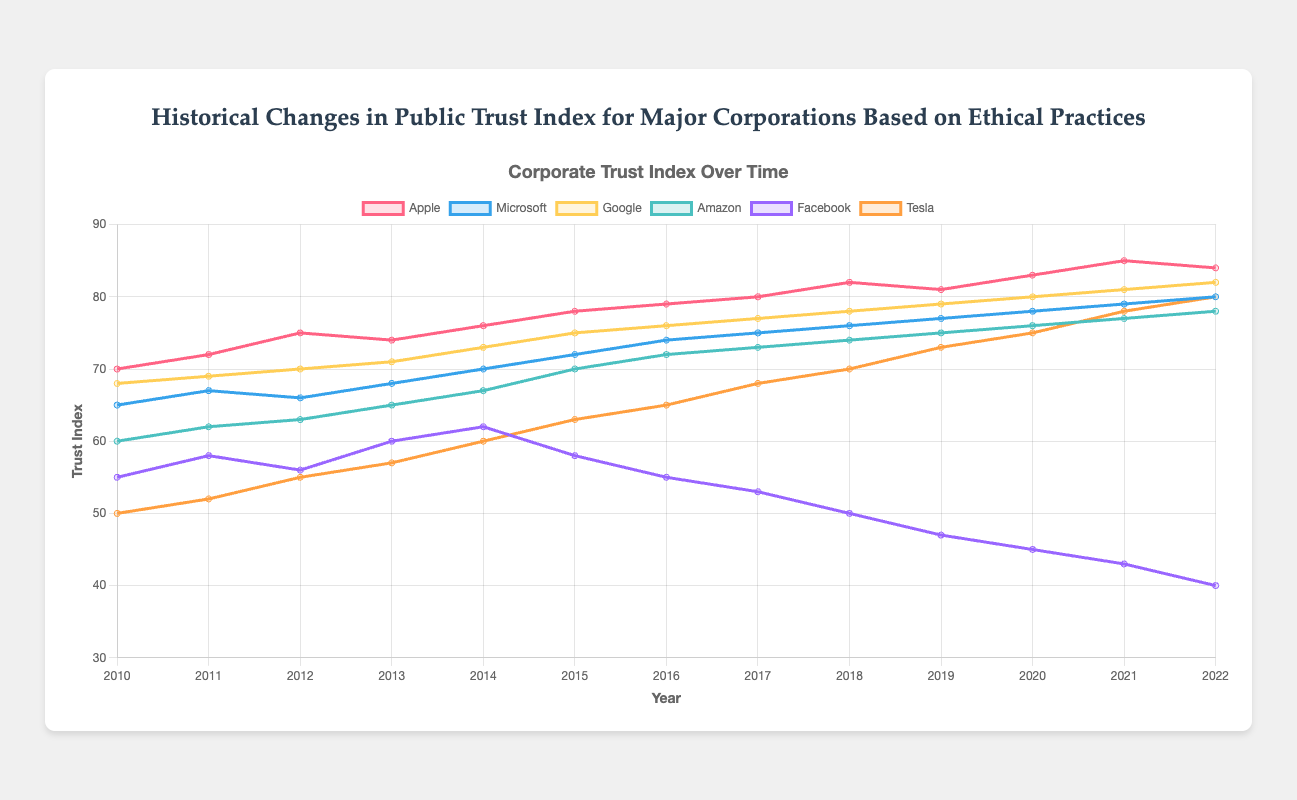What was the Trust Index of Apple in 2020? Locate the year 2020 on the x-axis and find the corresponding value of the Apple line, which is shown in pink.
Answer: 83 How much did Tesla's Trust Index increase from 2010 to 2022? Look at the Trust Index for Tesla in 2010 (50) and 2022 (80). Subtract the 2010 value from the 2022 value: 80 - 50.
Answer: 30 Between which years did Facebook see the steepest decline in its Trust Index? Observe the general trend of Facebook's (purple) line and identify the steepest negative slope between 2018 and 2019.
Answer: 2018 to 2019 Which company had the highest Trust Index in 2015? In 2015, compare the Trust Index values for all companies: Apple (78), Microsoft (72), Google (75), Amazon (70), Facebook (58), Tesla (63). Apple had the highest value.
Answer: Apple How many companies had an increase in Trust Index from 2015 to 2016? Identify and compare the Trust Index values for each company in 2015 and 2016. Apple (78 to 79), Microsoft (72 to 74), Google (75 to 76), Amazon (70 to 72), Facebook (58 to 55), Tesla (63 to 65). Five companies saw an increase in Trust Index.
Answer: 5 What is the average Trust Index of Microsoft between 2010 and 2022? Add up Microsoft's Trust Index values for each year (65, 67, 66, 68, 70, 72, 74, 75, 76, 77, 78, 79, 80) and divide by the number of years (13). (65 + 67 + 66 + 68 + 70 + 72 + 74 + 75 + 76 + 77 + 78 + 79 + 80) / 13 = 998 / 13 ≈ 76.77
Answer: 76.77 Which year's data does Apple have its highest Trust Index, and what was the value? Locate the highest point of the Apple line (pink) on the y-axis, which is in 2021 with a Trust Index of 85.
Answer: 2021, 85 Did Google's Trust Index ever surpass Microsoft's Trust Index, and if so, when? Compare the trend lines of Google (yellow) and Microsoft (blue) over time and observe that Google's Trust Index consistently surpassed Microsoft's since around 2011.
Answer: Yes, starting from 2011 Compare the Trust Index of Amazon and Tesla in 2013. Which company had a higher value, and by how much? Find the Trust Index values for Amazon (65) and Tesla (57) in 2013. Amazon's index is higher: 65 - 57 = 8.
Answer: Amazon, by 8 What was the Trust Index trend for all companies from 2020 to 2022? Observe the lines' directions from 2020 to 2022: Apple slightly decreases, Microsoft increases, Google increases, Amazon increases, Facebook decreases, Tesla increases.
Answer: Mostly increasing, except for Apple and Facebook 